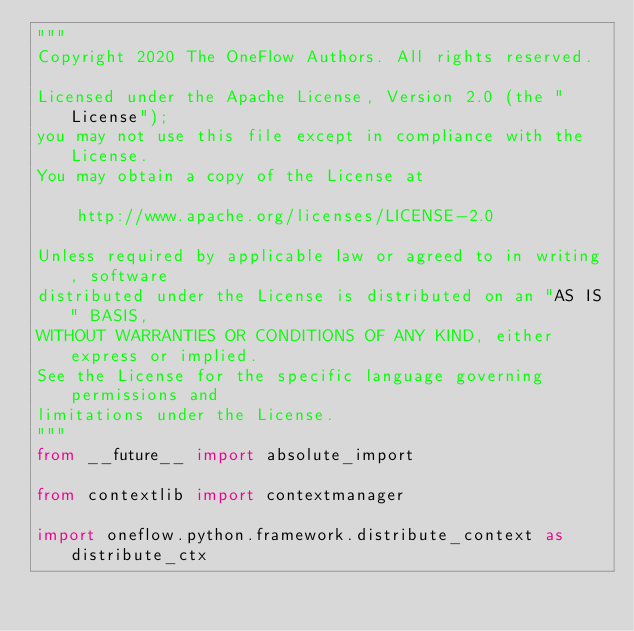Convert code to text. <code><loc_0><loc_0><loc_500><loc_500><_Python_>"""
Copyright 2020 The OneFlow Authors. All rights reserved.

Licensed under the Apache License, Version 2.0 (the "License");
you may not use this file except in compliance with the License.
You may obtain a copy of the License at

    http://www.apache.org/licenses/LICENSE-2.0

Unless required by applicable law or agreed to in writing, software
distributed under the License is distributed on an "AS IS" BASIS,
WITHOUT WARRANTIES OR CONDITIONS OF ANY KIND, either express or implied.
See the License for the specific language governing permissions and
limitations under the License.
"""
from __future__ import absolute_import

from contextlib import contextmanager

import oneflow.python.framework.distribute_context as distribute_ctx</code> 